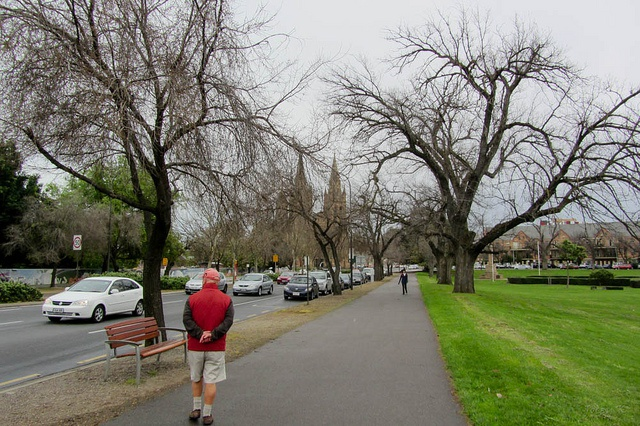Describe the objects in this image and their specific colors. I can see people in gray, brown, maroon, black, and darkgray tones, car in gray, darkgray, lightgray, and black tones, bench in gray, maroon, and brown tones, car in gray, darkgray, black, and lightgray tones, and bench in gray, black, and maroon tones in this image. 